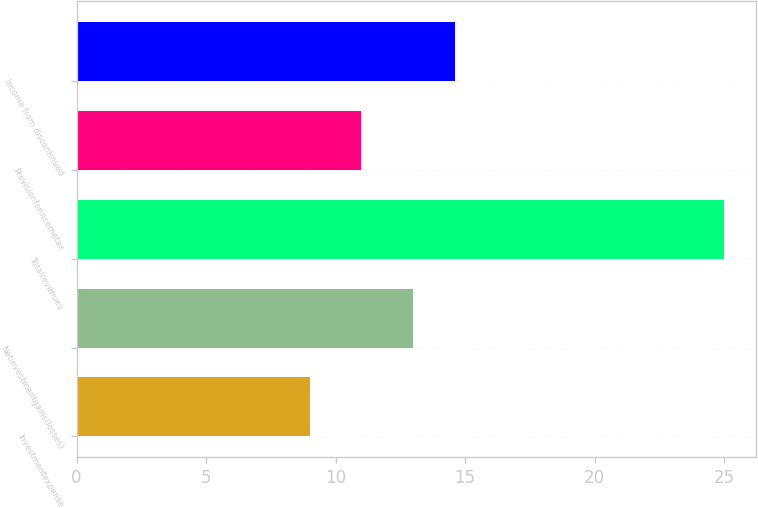<chart> <loc_0><loc_0><loc_500><loc_500><bar_chart><fcel>Investmentexpense<fcel>Netinvestmentgains(losses)<fcel>Totalrevenues<fcel>Provisionforincometax<fcel>Income from discontinued<nl><fcel>9<fcel>13<fcel>25<fcel>11<fcel>14.6<nl></chart> 